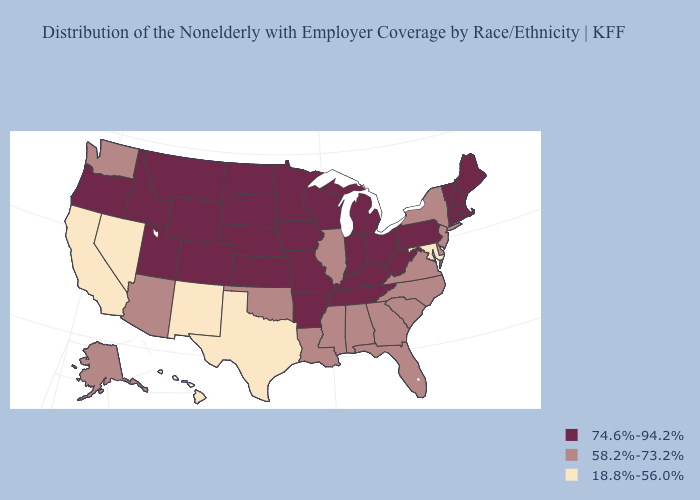Is the legend a continuous bar?
Concise answer only. No. Name the states that have a value in the range 74.6%-94.2%?
Short answer required. Arkansas, Colorado, Connecticut, Idaho, Indiana, Iowa, Kansas, Kentucky, Maine, Massachusetts, Michigan, Minnesota, Missouri, Montana, Nebraska, New Hampshire, North Dakota, Ohio, Oregon, Pennsylvania, Rhode Island, South Dakota, Tennessee, Utah, Vermont, West Virginia, Wisconsin, Wyoming. What is the highest value in the USA?
Keep it brief. 74.6%-94.2%. Does Oklahoma have the highest value in the USA?
Give a very brief answer. No. Does Maine have the highest value in the USA?
Answer briefly. Yes. What is the value of Rhode Island?
Short answer required. 74.6%-94.2%. How many symbols are there in the legend?
Give a very brief answer. 3. What is the lowest value in the USA?
Quick response, please. 18.8%-56.0%. Does Montana have a higher value than Texas?
Quick response, please. Yes. What is the value of California?
Keep it brief. 18.8%-56.0%. Does the first symbol in the legend represent the smallest category?
Answer briefly. No. What is the value of Alaska?
Be succinct. 58.2%-73.2%. Name the states that have a value in the range 18.8%-56.0%?
Answer briefly. California, Hawaii, Maryland, Nevada, New Mexico, Texas. What is the highest value in states that border Nevada?
Quick response, please. 74.6%-94.2%. What is the highest value in the USA?
Concise answer only. 74.6%-94.2%. 